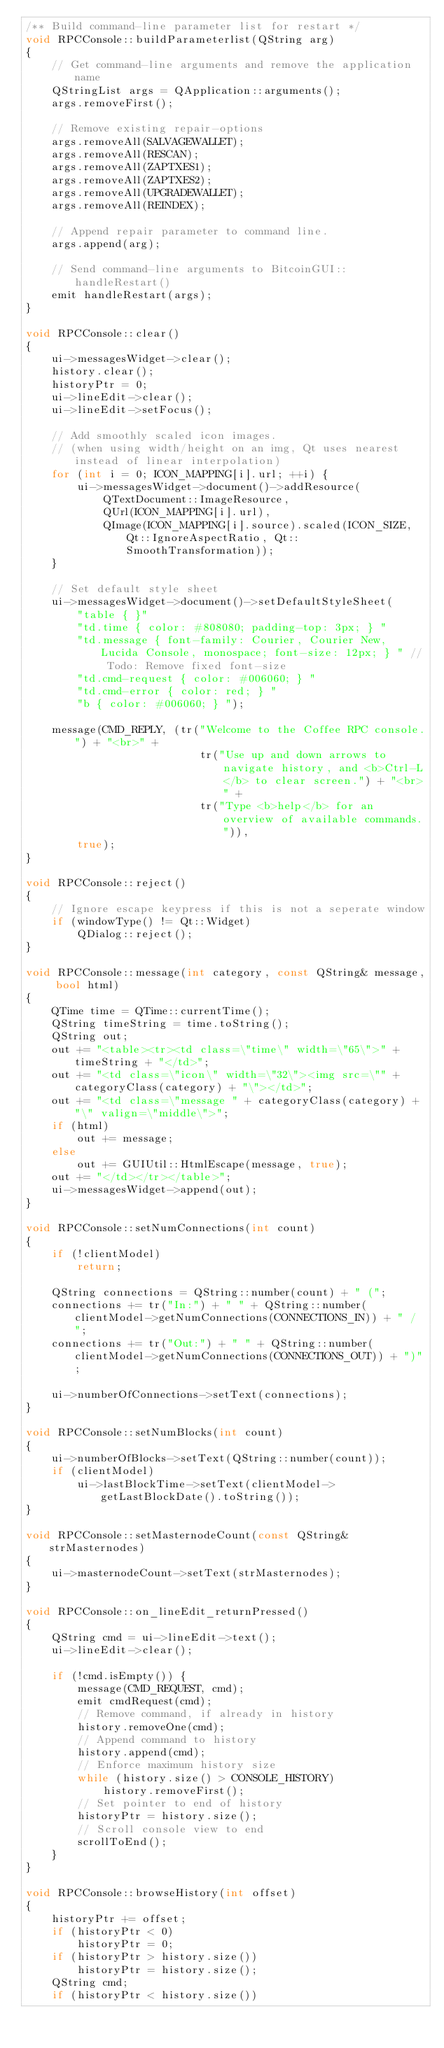<code> <loc_0><loc_0><loc_500><loc_500><_C++_>/** Build command-line parameter list for restart */
void RPCConsole::buildParameterlist(QString arg)
{
    // Get command-line arguments and remove the application name
    QStringList args = QApplication::arguments();
    args.removeFirst();

    // Remove existing repair-options
    args.removeAll(SALVAGEWALLET);
    args.removeAll(RESCAN);
    args.removeAll(ZAPTXES1);
    args.removeAll(ZAPTXES2);
    args.removeAll(UPGRADEWALLET);
    args.removeAll(REINDEX);

    // Append repair parameter to command line.
    args.append(arg);

    // Send command-line arguments to BitcoinGUI::handleRestart()
    emit handleRestart(args);
}

void RPCConsole::clear()
{
    ui->messagesWidget->clear();
    history.clear();
    historyPtr = 0;
    ui->lineEdit->clear();
    ui->lineEdit->setFocus();

    // Add smoothly scaled icon images.
    // (when using width/height on an img, Qt uses nearest instead of linear interpolation)
    for (int i = 0; ICON_MAPPING[i].url; ++i) {
        ui->messagesWidget->document()->addResource(
            QTextDocument::ImageResource,
            QUrl(ICON_MAPPING[i].url),
            QImage(ICON_MAPPING[i].source).scaled(ICON_SIZE, Qt::IgnoreAspectRatio, Qt::SmoothTransformation));
    }

    // Set default style sheet
    ui->messagesWidget->document()->setDefaultStyleSheet(
        "table { }"
        "td.time { color: #808080; padding-top: 3px; } "
        "td.message { font-family: Courier, Courier New, Lucida Console, monospace; font-size: 12px; } " // Todo: Remove fixed font-size
        "td.cmd-request { color: #006060; } "
        "td.cmd-error { color: red; } "
        "b { color: #006060; } ");

    message(CMD_REPLY, (tr("Welcome to the Coffee RPC console.") + "<br>" +
                           tr("Use up and down arrows to navigate history, and <b>Ctrl-L</b> to clear screen.") + "<br>" +
                           tr("Type <b>help</b> for an overview of available commands.")),
        true);
}

void RPCConsole::reject()
{
    // Ignore escape keypress if this is not a seperate window
    if (windowType() != Qt::Widget)
        QDialog::reject();
}

void RPCConsole::message(int category, const QString& message, bool html)
{
    QTime time = QTime::currentTime();
    QString timeString = time.toString();
    QString out;
    out += "<table><tr><td class=\"time\" width=\"65\">" + timeString + "</td>";
    out += "<td class=\"icon\" width=\"32\"><img src=\"" + categoryClass(category) + "\"></td>";
    out += "<td class=\"message " + categoryClass(category) + "\" valign=\"middle\">";
    if (html)
        out += message;
    else
        out += GUIUtil::HtmlEscape(message, true);
    out += "</td></tr></table>";
    ui->messagesWidget->append(out);
}

void RPCConsole::setNumConnections(int count)
{
    if (!clientModel)
        return;

    QString connections = QString::number(count) + " (";
    connections += tr("In:") + " " + QString::number(clientModel->getNumConnections(CONNECTIONS_IN)) + " / ";
    connections += tr("Out:") + " " + QString::number(clientModel->getNumConnections(CONNECTIONS_OUT)) + ")";

    ui->numberOfConnections->setText(connections);
}

void RPCConsole::setNumBlocks(int count)
{
    ui->numberOfBlocks->setText(QString::number(count));
    if (clientModel)
        ui->lastBlockTime->setText(clientModel->getLastBlockDate().toString());
}

void RPCConsole::setMasternodeCount(const QString& strMasternodes)
{
    ui->masternodeCount->setText(strMasternodes);
}

void RPCConsole::on_lineEdit_returnPressed()
{
    QString cmd = ui->lineEdit->text();
    ui->lineEdit->clear();

    if (!cmd.isEmpty()) {
        message(CMD_REQUEST, cmd);
        emit cmdRequest(cmd);
        // Remove command, if already in history
        history.removeOne(cmd);
        // Append command to history
        history.append(cmd);
        // Enforce maximum history size
        while (history.size() > CONSOLE_HISTORY)
            history.removeFirst();
        // Set pointer to end of history
        historyPtr = history.size();
        // Scroll console view to end
        scrollToEnd();
    }
}

void RPCConsole::browseHistory(int offset)
{
    historyPtr += offset;
    if (historyPtr < 0)
        historyPtr = 0;
    if (historyPtr > history.size())
        historyPtr = history.size();
    QString cmd;
    if (historyPtr < history.size())</code> 